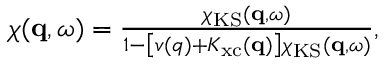Convert formula to latex. <formula><loc_0><loc_0><loc_500><loc_500>\begin{array} { r } { \chi ( q , \omega ) = \frac { \chi _ { K S } ( q , \omega ) } { 1 - \left [ v ( q ) + K _ { x c } ( q ) \right ] \chi _ { K S } ( q , \omega ) } , } \end{array}</formula> 